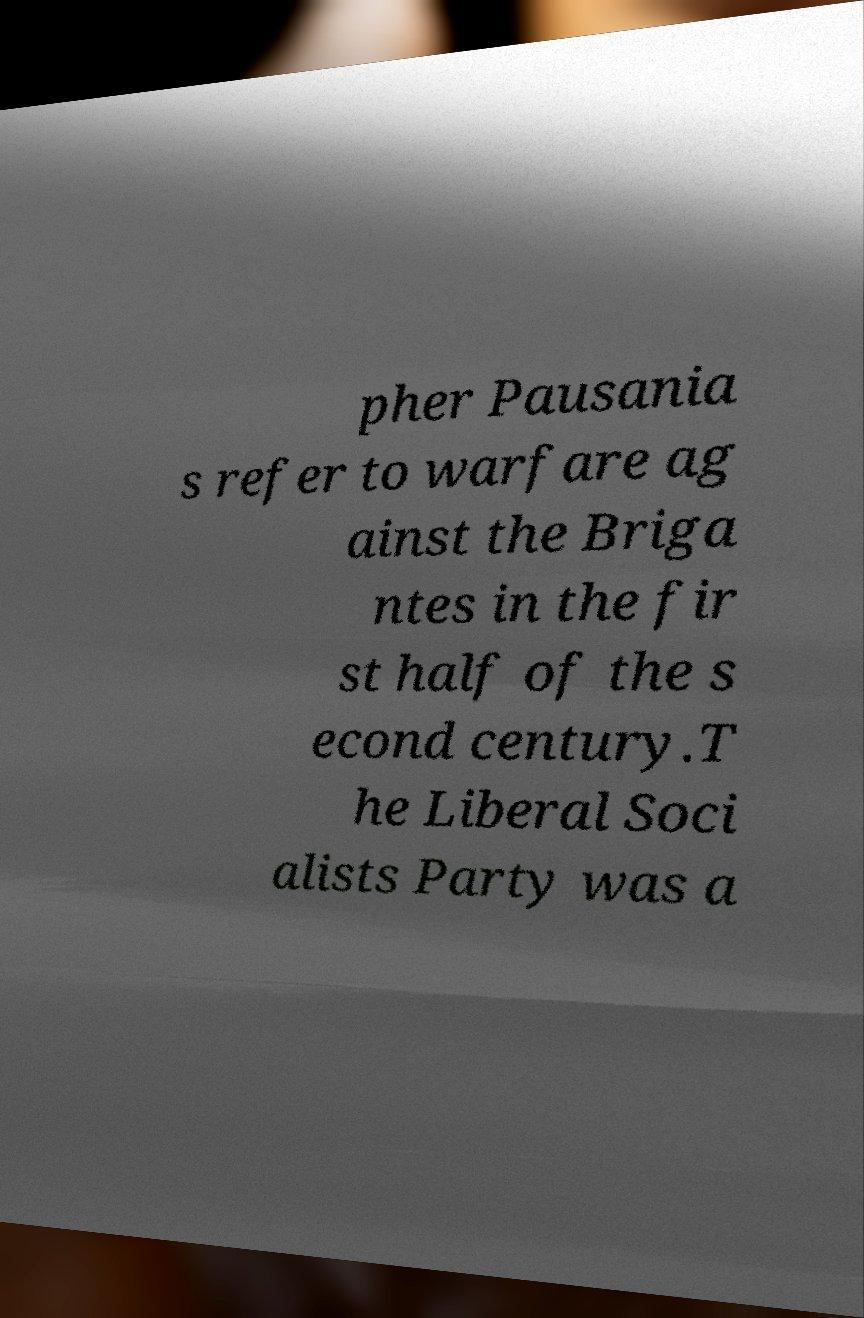Can you read and provide the text displayed in the image?This photo seems to have some interesting text. Can you extract and type it out for me? pher Pausania s refer to warfare ag ainst the Briga ntes in the fir st half of the s econd century.T he Liberal Soci alists Party was a 